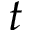<formula> <loc_0><loc_0><loc_500><loc_500>t</formula> 